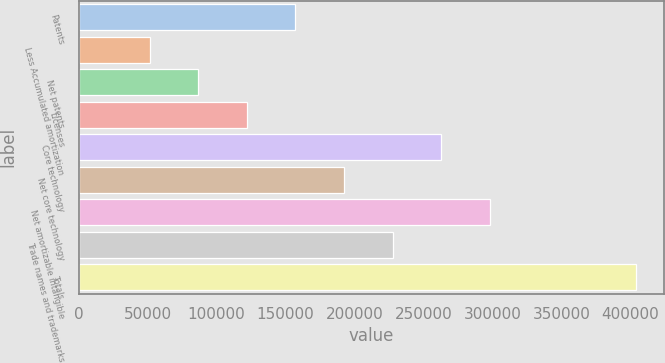<chart> <loc_0><loc_0><loc_500><loc_500><bar_chart><fcel>Patents<fcel>Less Accumulated amortization<fcel>Net patents<fcel>Licenses<fcel>Core technology<fcel>Net core technology<fcel>Net amortizable intangible<fcel>Trade names and trademarks<fcel>Totals<nl><fcel>157279<fcel>51532<fcel>86780.9<fcel>122030<fcel>263025<fcel>192528<fcel>298274<fcel>227776<fcel>404021<nl></chart> 